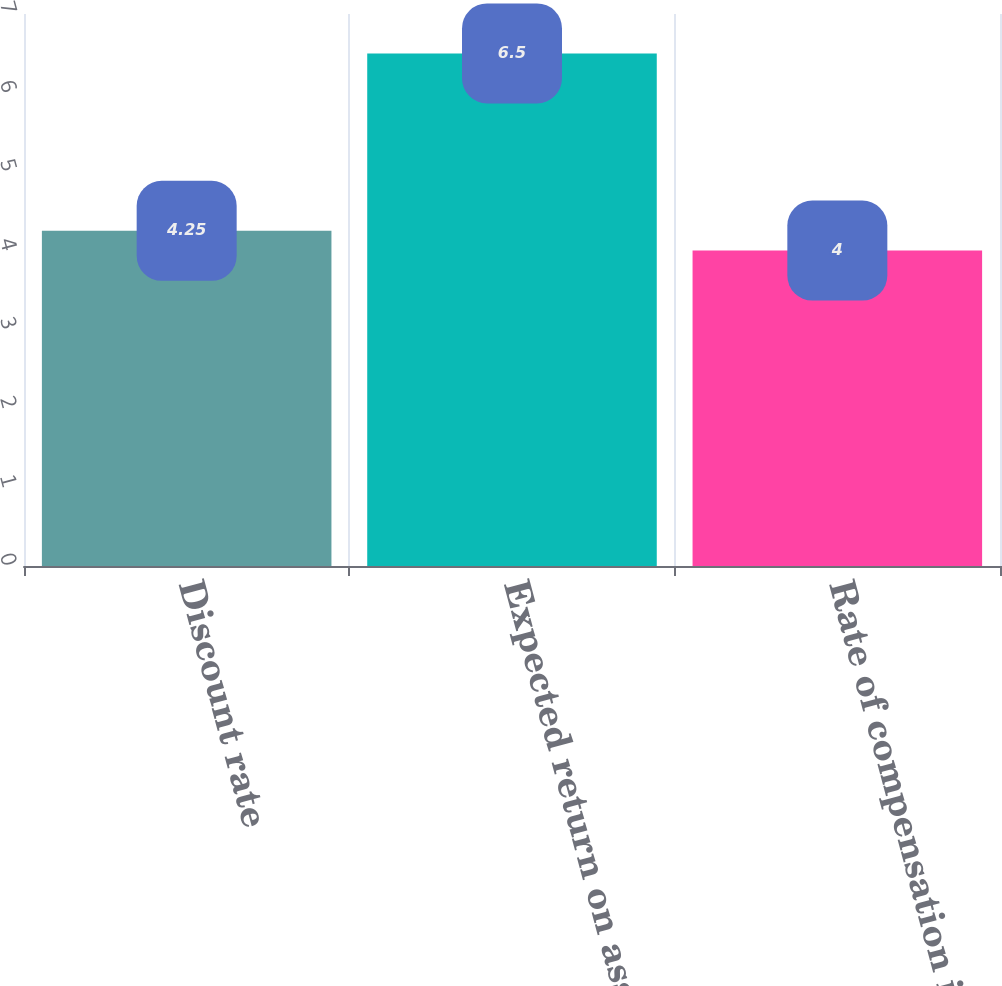Convert chart. <chart><loc_0><loc_0><loc_500><loc_500><bar_chart><fcel>Discount rate<fcel>Expected return on assets<fcel>Rate of compensation increase<nl><fcel>4.25<fcel>6.5<fcel>4<nl></chart> 